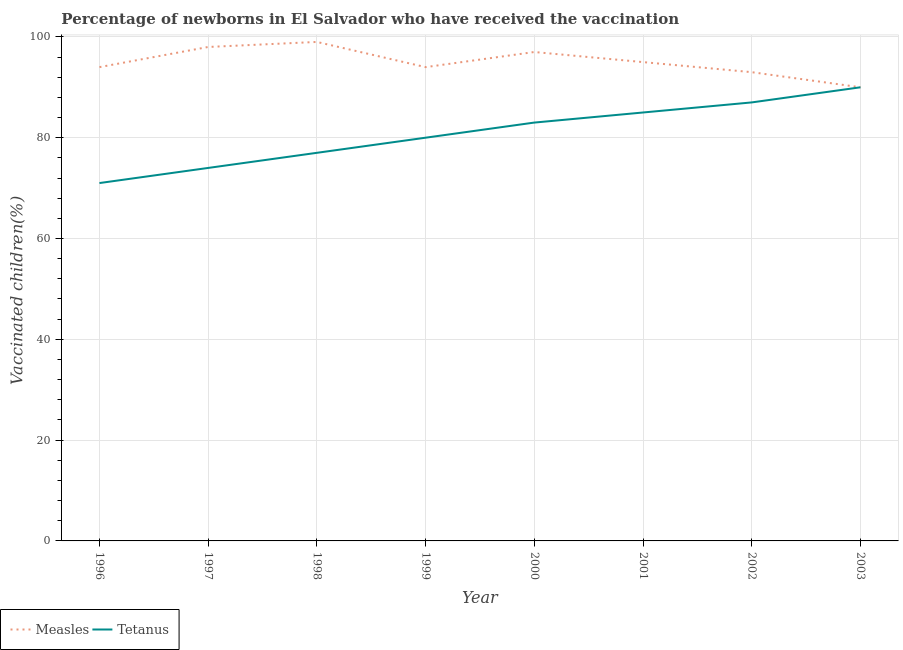How many different coloured lines are there?
Provide a succinct answer. 2. Does the line corresponding to percentage of newborns who received vaccination for measles intersect with the line corresponding to percentage of newborns who received vaccination for tetanus?
Offer a very short reply. Yes. What is the percentage of newborns who received vaccination for tetanus in 1997?
Make the answer very short. 74. Across all years, what is the maximum percentage of newborns who received vaccination for measles?
Provide a short and direct response. 99. Across all years, what is the minimum percentage of newborns who received vaccination for measles?
Provide a short and direct response. 90. In which year was the percentage of newborns who received vaccination for measles minimum?
Offer a very short reply. 2003. What is the total percentage of newborns who received vaccination for measles in the graph?
Keep it short and to the point. 760. What is the difference between the percentage of newborns who received vaccination for tetanus in 1997 and that in 2002?
Your response must be concise. -13. What is the difference between the percentage of newborns who received vaccination for measles in 2001 and the percentage of newborns who received vaccination for tetanus in 2002?
Keep it short and to the point. 8. In the year 1996, what is the difference between the percentage of newborns who received vaccination for tetanus and percentage of newborns who received vaccination for measles?
Offer a terse response. -23. What is the ratio of the percentage of newborns who received vaccination for tetanus in 1997 to that in 1998?
Offer a terse response. 0.96. Is the percentage of newborns who received vaccination for measles in 2000 less than that in 2001?
Provide a short and direct response. No. What is the difference between the highest and the second highest percentage of newborns who received vaccination for tetanus?
Your response must be concise. 3. What is the difference between the highest and the lowest percentage of newborns who received vaccination for tetanus?
Make the answer very short. 19. Is the sum of the percentage of newborns who received vaccination for tetanus in 1996 and 2001 greater than the maximum percentage of newborns who received vaccination for measles across all years?
Keep it short and to the point. Yes. Does the percentage of newborns who received vaccination for tetanus monotonically increase over the years?
Ensure brevity in your answer.  Yes. Is the percentage of newborns who received vaccination for measles strictly greater than the percentage of newborns who received vaccination for tetanus over the years?
Give a very brief answer. No. Is the percentage of newborns who received vaccination for measles strictly less than the percentage of newborns who received vaccination for tetanus over the years?
Keep it short and to the point. No. How many lines are there?
Your response must be concise. 2. How many years are there in the graph?
Ensure brevity in your answer.  8. What is the difference between two consecutive major ticks on the Y-axis?
Offer a very short reply. 20. Are the values on the major ticks of Y-axis written in scientific E-notation?
Give a very brief answer. No. Does the graph contain any zero values?
Ensure brevity in your answer.  No. Does the graph contain grids?
Your response must be concise. Yes. Where does the legend appear in the graph?
Your answer should be very brief. Bottom left. What is the title of the graph?
Offer a terse response. Percentage of newborns in El Salvador who have received the vaccination. What is the label or title of the Y-axis?
Offer a very short reply. Vaccinated children(%)
. What is the Vaccinated children(%)
 of Measles in 1996?
Your answer should be compact. 94. What is the Vaccinated children(%)
 of Tetanus in 1996?
Offer a terse response. 71. What is the Vaccinated children(%)
 in Measles in 1997?
Keep it short and to the point. 98. What is the Vaccinated children(%)
 of Tetanus in 1997?
Provide a succinct answer. 74. What is the Vaccinated children(%)
 of Measles in 1999?
Provide a short and direct response. 94. What is the Vaccinated children(%)
 in Measles in 2000?
Give a very brief answer. 97. What is the Vaccinated children(%)
 in Tetanus in 2000?
Your answer should be compact. 83. What is the Vaccinated children(%)
 in Tetanus in 2001?
Offer a very short reply. 85. What is the Vaccinated children(%)
 of Measles in 2002?
Provide a short and direct response. 93. What is the Vaccinated children(%)
 in Measles in 2003?
Your answer should be very brief. 90. What is the Vaccinated children(%)
 in Tetanus in 2003?
Provide a succinct answer. 90. Across all years, what is the maximum Vaccinated children(%)
 in Measles?
Your answer should be very brief. 99. Across all years, what is the maximum Vaccinated children(%)
 in Tetanus?
Ensure brevity in your answer.  90. What is the total Vaccinated children(%)
 in Measles in the graph?
Give a very brief answer. 760. What is the total Vaccinated children(%)
 of Tetanus in the graph?
Provide a succinct answer. 647. What is the difference between the Vaccinated children(%)
 in Tetanus in 1996 and that in 1997?
Offer a very short reply. -3. What is the difference between the Vaccinated children(%)
 of Tetanus in 1996 and that in 1999?
Your answer should be very brief. -9. What is the difference between the Vaccinated children(%)
 in Measles in 1996 and that in 2000?
Ensure brevity in your answer.  -3. What is the difference between the Vaccinated children(%)
 of Tetanus in 1996 and that in 2000?
Give a very brief answer. -12. What is the difference between the Vaccinated children(%)
 in Measles in 1996 and that in 2001?
Your answer should be very brief. -1. What is the difference between the Vaccinated children(%)
 of Tetanus in 1996 and that in 2002?
Make the answer very short. -16. What is the difference between the Vaccinated children(%)
 in Measles in 1997 and that in 1999?
Provide a short and direct response. 4. What is the difference between the Vaccinated children(%)
 of Tetanus in 1997 and that in 1999?
Your response must be concise. -6. What is the difference between the Vaccinated children(%)
 in Measles in 1997 and that in 2000?
Your response must be concise. 1. What is the difference between the Vaccinated children(%)
 of Tetanus in 1997 and that in 2001?
Your answer should be compact. -11. What is the difference between the Vaccinated children(%)
 of Measles in 1997 and that in 2002?
Provide a short and direct response. 5. What is the difference between the Vaccinated children(%)
 of Measles in 1997 and that in 2003?
Ensure brevity in your answer.  8. What is the difference between the Vaccinated children(%)
 of Measles in 1998 and that in 1999?
Your answer should be compact. 5. What is the difference between the Vaccinated children(%)
 of Measles in 1998 and that in 2000?
Provide a succinct answer. 2. What is the difference between the Vaccinated children(%)
 in Tetanus in 1998 and that in 2000?
Your answer should be very brief. -6. What is the difference between the Vaccinated children(%)
 of Measles in 1998 and that in 2001?
Keep it short and to the point. 4. What is the difference between the Vaccinated children(%)
 of Measles in 1998 and that in 2002?
Offer a very short reply. 6. What is the difference between the Vaccinated children(%)
 of Tetanus in 1998 and that in 2002?
Ensure brevity in your answer.  -10. What is the difference between the Vaccinated children(%)
 in Measles in 1998 and that in 2003?
Ensure brevity in your answer.  9. What is the difference between the Vaccinated children(%)
 in Tetanus in 1998 and that in 2003?
Your response must be concise. -13. What is the difference between the Vaccinated children(%)
 in Tetanus in 1999 and that in 2000?
Offer a terse response. -3. What is the difference between the Vaccinated children(%)
 of Tetanus in 1999 and that in 2003?
Provide a short and direct response. -10. What is the difference between the Vaccinated children(%)
 in Tetanus in 2000 and that in 2001?
Your response must be concise. -2. What is the difference between the Vaccinated children(%)
 of Measles in 2000 and that in 2002?
Your response must be concise. 4. What is the difference between the Vaccinated children(%)
 of Measles in 2000 and that in 2003?
Ensure brevity in your answer.  7. What is the difference between the Vaccinated children(%)
 in Tetanus in 2000 and that in 2003?
Your answer should be compact. -7. What is the difference between the Vaccinated children(%)
 of Measles in 2001 and that in 2002?
Provide a succinct answer. 2. What is the difference between the Vaccinated children(%)
 in Measles in 2002 and that in 2003?
Make the answer very short. 3. What is the difference between the Vaccinated children(%)
 in Tetanus in 2002 and that in 2003?
Keep it short and to the point. -3. What is the difference between the Vaccinated children(%)
 in Measles in 1996 and the Vaccinated children(%)
 in Tetanus in 1997?
Offer a very short reply. 20. What is the difference between the Vaccinated children(%)
 in Measles in 1996 and the Vaccinated children(%)
 in Tetanus in 1999?
Offer a terse response. 14. What is the difference between the Vaccinated children(%)
 in Measles in 1996 and the Vaccinated children(%)
 in Tetanus in 2000?
Your answer should be compact. 11. What is the difference between the Vaccinated children(%)
 in Measles in 1996 and the Vaccinated children(%)
 in Tetanus in 2003?
Offer a very short reply. 4. What is the difference between the Vaccinated children(%)
 in Measles in 1997 and the Vaccinated children(%)
 in Tetanus in 1999?
Your response must be concise. 18. What is the difference between the Vaccinated children(%)
 of Measles in 1997 and the Vaccinated children(%)
 of Tetanus in 2001?
Keep it short and to the point. 13. What is the difference between the Vaccinated children(%)
 in Measles in 1997 and the Vaccinated children(%)
 in Tetanus in 2002?
Provide a succinct answer. 11. What is the difference between the Vaccinated children(%)
 in Measles in 1998 and the Vaccinated children(%)
 in Tetanus in 2001?
Your response must be concise. 14. What is the difference between the Vaccinated children(%)
 in Measles in 1998 and the Vaccinated children(%)
 in Tetanus in 2002?
Give a very brief answer. 12. What is the difference between the Vaccinated children(%)
 in Measles in 1999 and the Vaccinated children(%)
 in Tetanus in 2002?
Provide a succinct answer. 7. What is the difference between the Vaccinated children(%)
 of Measles in 2001 and the Vaccinated children(%)
 of Tetanus in 2002?
Provide a succinct answer. 8. What is the difference between the Vaccinated children(%)
 in Measles in 2002 and the Vaccinated children(%)
 in Tetanus in 2003?
Give a very brief answer. 3. What is the average Vaccinated children(%)
 in Tetanus per year?
Your response must be concise. 80.88. In the year 1999, what is the difference between the Vaccinated children(%)
 in Measles and Vaccinated children(%)
 in Tetanus?
Your answer should be compact. 14. In the year 2002, what is the difference between the Vaccinated children(%)
 in Measles and Vaccinated children(%)
 in Tetanus?
Ensure brevity in your answer.  6. What is the ratio of the Vaccinated children(%)
 in Measles in 1996 to that in 1997?
Provide a succinct answer. 0.96. What is the ratio of the Vaccinated children(%)
 in Tetanus in 1996 to that in 1997?
Offer a very short reply. 0.96. What is the ratio of the Vaccinated children(%)
 of Measles in 1996 to that in 1998?
Ensure brevity in your answer.  0.95. What is the ratio of the Vaccinated children(%)
 of Tetanus in 1996 to that in 1998?
Provide a succinct answer. 0.92. What is the ratio of the Vaccinated children(%)
 of Tetanus in 1996 to that in 1999?
Offer a terse response. 0.89. What is the ratio of the Vaccinated children(%)
 of Measles in 1996 to that in 2000?
Keep it short and to the point. 0.97. What is the ratio of the Vaccinated children(%)
 of Tetanus in 1996 to that in 2000?
Offer a terse response. 0.86. What is the ratio of the Vaccinated children(%)
 in Tetanus in 1996 to that in 2001?
Your answer should be very brief. 0.84. What is the ratio of the Vaccinated children(%)
 of Measles in 1996 to that in 2002?
Provide a succinct answer. 1.01. What is the ratio of the Vaccinated children(%)
 in Tetanus in 1996 to that in 2002?
Make the answer very short. 0.82. What is the ratio of the Vaccinated children(%)
 of Measles in 1996 to that in 2003?
Give a very brief answer. 1.04. What is the ratio of the Vaccinated children(%)
 in Tetanus in 1996 to that in 2003?
Give a very brief answer. 0.79. What is the ratio of the Vaccinated children(%)
 in Tetanus in 1997 to that in 1998?
Your answer should be very brief. 0.96. What is the ratio of the Vaccinated children(%)
 in Measles in 1997 to that in 1999?
Ensure brevity in your answer.  1.04. What is the ratio of the Vaccinated children(%)
 of Tetanus in 1997 to that in 1999?
Ensure brevity in your answer.  0.93. What is the ratio of the Vaccinated children(%)
 in Measles in 1997 to that in 2000?
Provide a short and direct response. 1.01. What is the ratio of the Vaccinated children(%)
 of Tetanus in 1997 to that in 2000?
Provide a short and direct response. 0.89. What is the ratio of the Vaccinated children(%)
 in Measles in 1997 to that in 2001?
Your answer should be very brief. 1.03. What is the ratio of the Vaccinated children(%)
 in Tetanus in 1997 to that in 2001?
Provide a succinct answer. 0.87. What is the ratio of the Vaccinated children(%)
 of Measles in 1997 to that in 2002?
Ensure brevity in your answer.  1.05. What is the ratio of the Vaccinated children(%)
 in Tetanus in 1997 to that in 2002?
Ensure brevity in your answer.  0.85. What is the ratio of the Vaccinated children(%)
 in Measles in 1997 to that in 2003?
Offer a terse response. 1.09. What is the ratio of the Vaccinated children(%)
 in Tetanus in 1997 to that in 2003?
Your answer should be compact. 0.82. What is the ratio of the Vaccinated children(%)
 in Measles in 1998 to that in 1999?
Provide a short and direct response. 1.05. What is the ratio of the Vaccinated children(%)
 of Tetanus in 1998 to that in 1999?
Provide a succinct answer. 0.96. What is the ratio of the Vaccinated children(%)
 in Measles in 1998 to that in 2000?
Offer a terse response. 1.02. What is the ratio of the Vaccinated children(%)
 in Tetanus in 1998 to that in 2000?
Provide a succinct answer. 0.93. What is the ratio of the Vaccinated children(%)
 of Measles in 1998 to that in 2001?
Provide a succinct answer. 1.04. What is the ratio of the Vaccinated children(%)
 of Tetanus in 1998 to that in 2001?
Your response must be concise. 0.91. What is the ratio of the Vaccinated children(%)
 in Measles in 1998 to that in 2002?
Ensure brevity in your answer.  1.06. What is the ratio of the Vaccinated children(%)
 in Tetanus in 1998 to that in 2002?
Your answer should be compact. 0.89. What is the ratio of the Vaccinated children(%)
 in Measles in 1998 to that in 2003?
Offer a very short reply. 1.1. What is the ratio of the Vaccinated children(%)
 of Tetanus in 1998 to that in 2003?
Keep it short and to the point. 0.86. What is the ratio of the Vaccinated children(%)
 in Measles in 1999 to that in 2000?
Offer a terse response. 0.97. What is the ratio of the Vaccinated children(%)
 of Tetanus in 1999 to that in 2000?
Offer a terse response. 0.96. What is the ratio of the Vaccinated children(%)
 in Tetanus in 1999 to that in 2001?
Offer a very short reply. 0.94. What is the ratio of the Vaccinated children(%)
 in Measles in 1999 to that in 2002?
Offer a terse response. 1.01. What is the ratio of the Vaccinated children(%)
 in Tetanus in 1999 to that in 2002?
Ensure brevity in your answer.  0.92. What is the ratio of the Vaccinated children(%)
 of Measles in 1999 to that in 2003?
Give a very brief answer. 1.04. What is the ratio of the Vaccinated children(%)
 of Tetanus in 1999 to that in 2003?
Give a very brief answer. 0.89. What is the ratio of the Vaccinated children(%)
 of Measles in 2000 to that in 2001?
Ensure brevity in your answer.  1.02. What is the ratio of the Vaccinated children(%)
 of Tetanus in 2000 to that in 2001?
Provide a short and direct response. 0.98. What is the ratio of the Vaccinated children(%)
 in Measles in 2000 to that in 2002?
Make the answer very short. 1.04. What is the ratio of the Vaccinated children(%)
 in Tetanus in 2000 to that in 2002?
Give a very brief answer. 0.95. What is the ratio of the Vaccinated children(%)
 of Measles in 2000 to that in 2003?
Your answer should be very brief. 1.08. What is the ratio of the Vaccinated children(%)
 in Tetanus in 2000 to that in 2003?
Provide a short and direct response. 0.92. What is the ratio of the Vaccinated children(%)
 in Measles in 2001 to that in 2002?
Provide a short and direct response. 1.02. What is the ratio of the Vaccinated children(%)
 in Measles in 2001 to that in 2003?
Your answer should be very brief. 1.06. What is the ratio of the Vaccinated children(%)
 of Tetanus in 2001 to that in 2003?
Make the answer very short. 0.94. What is the ratio of the Vaccinated children(%)
 in Measles in 2002 to that in 2003?
Offer a very short reply. 1.03. What is the ratio of the Vaccinated children(%)
 of Tetanus in 2002 to that in 2003?
Provide a short and direct response. 0.97. What is the difference between the highest and the second highest Vaccinated children(%)
 in Measles?
Keep it short and to the point. 1. What is the difference between the highest and the lowest Vaccinated children(%)
 of Tetanus?
Provide a succinct answer. 19. 